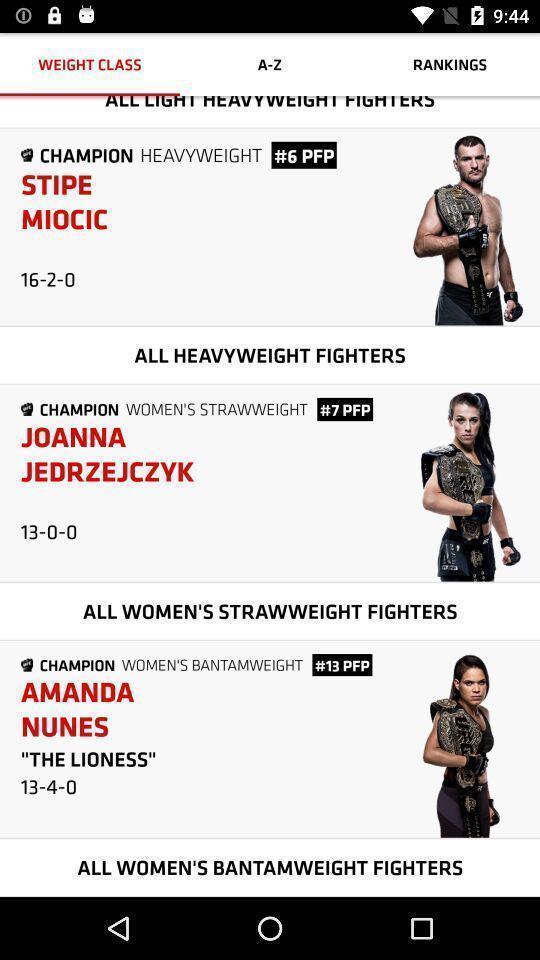Give me a summary of this screen capture. Screen displaying weight class with an application. 